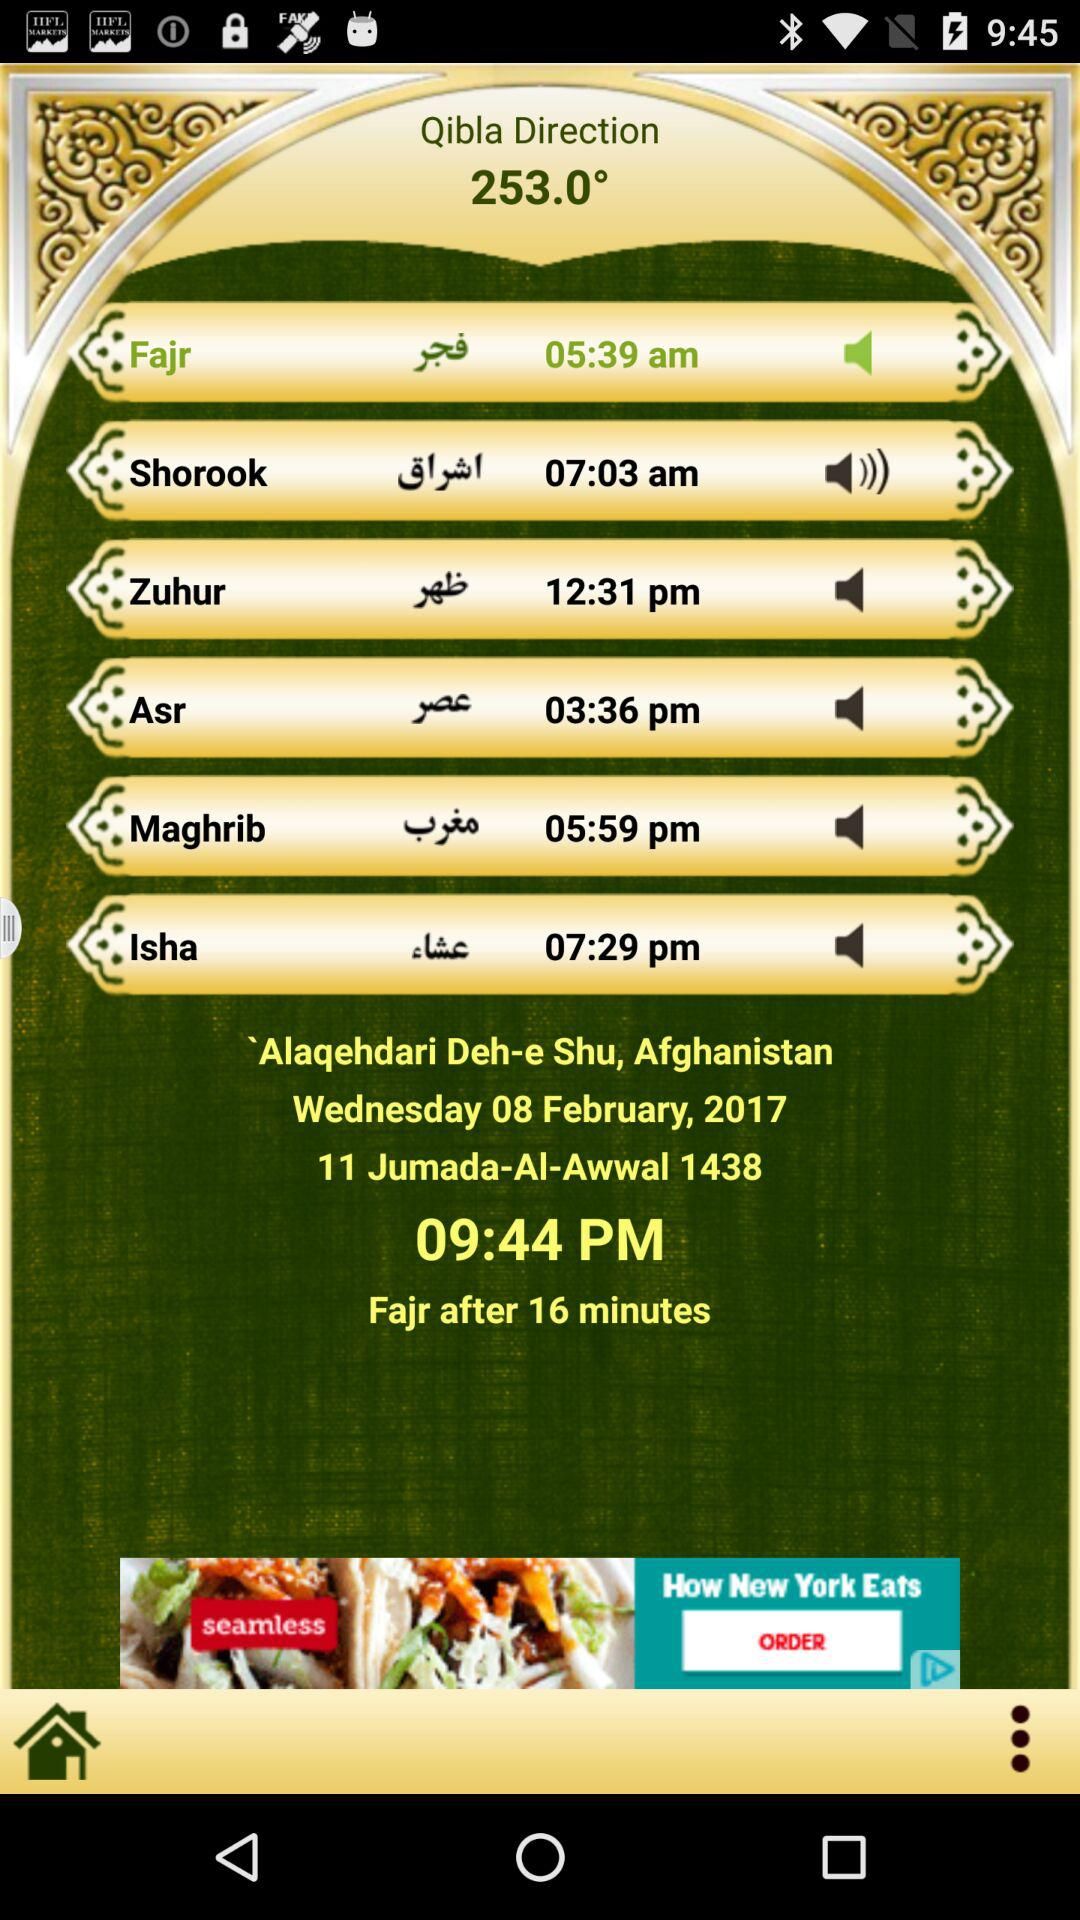What is the Qibla direction?
Answer the question using a single word or phrase. 253.0° 